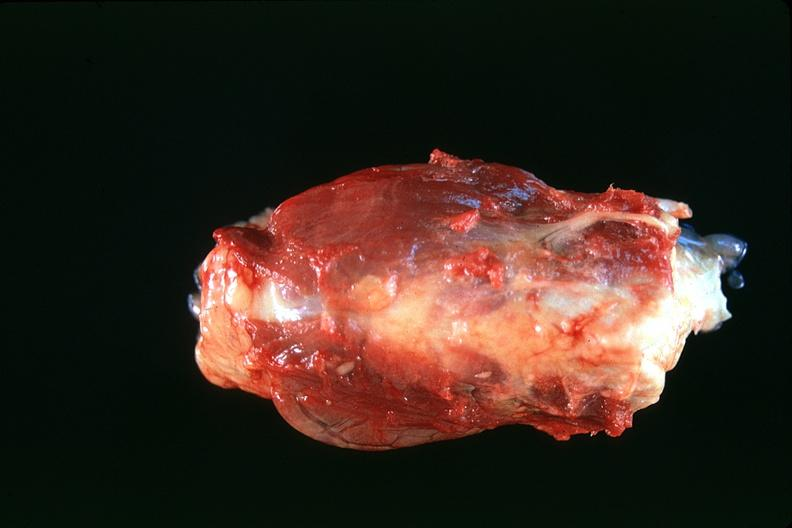what is present?
Answer the question using a single word or phrase. Endocrine 